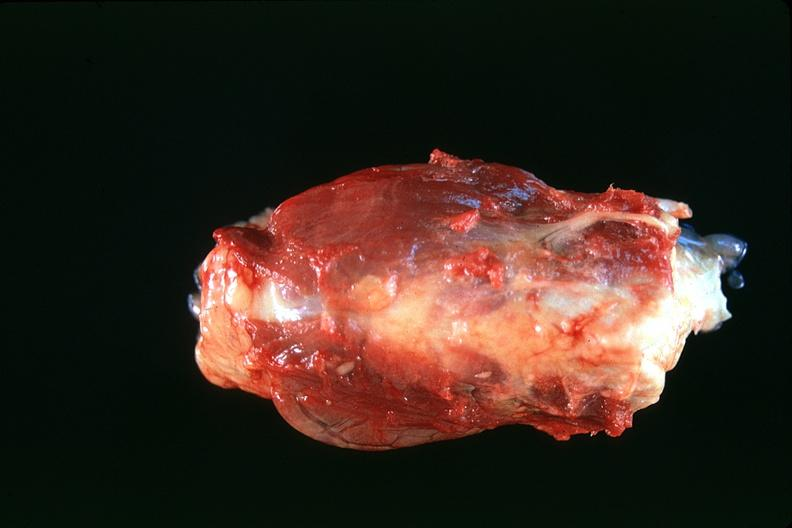what is present?
Answer the question using a single word or phrase. Endocrine 